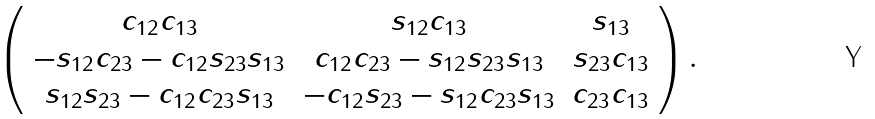Convert formula to latex. <formula><loc_0><loc_0><loc_500><loc_500>\left ( \begin{array} { c c c } c _ { 1 2 } c _ { 1 3 } & s _ { 1 2 } c _ { 1 3 } & s _ { 1 3 } \\ - s _ { 1 2 } c _ { 2 3 } - c _ { 1 2 } s _ { 2 3 } s _ { 1 3 } & c _ { 1 2 } c _ { 2 3 } - s _ { 1 2 } s _ { 2 3 } s _ { 1 3 } & s _ { 2 3 } c _ { 1 3 } \\ s _ { 1 2 } s _ { 2 3 } - c _ { 1 2 } c _ { 2 3 } s _ { 1 3 } & - c _ { 1 2 } s _ { 2 3 } - s _ { 1 2 } c _ { 2 3 } s _ { 1 3 } & c _ { 2 3 } c _ { 1 3 } \end{array} \right ) .</formula> 